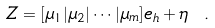<formula> <loc_0><loc_0><loc_500><loc_500>Z = [ \mu _ { 1 } | \mu _ { 2 } | \cdots | \mu _ { m } ] e _ { h } + \eta \ .</formula> 